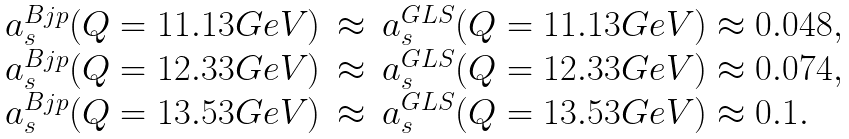<formula> <loc_0><loc_0><loc_500><loc_500>\begin{array} { r c l } a _ { s } ^ { B j p } ( Q = 1 1 . 1 3 G e V ) & \approx & a _ { s } ^ { G L S } ( Q = 1 1 . 1 3 G e V ) \approx 0 . 0 4 8 , \\ a _ { s } ^ { B j p } ( Q = 1 2 . 3 3 G e V ) & \approx & a _ { s } ^ { G L S } ( Q = 1 2 . 3 3 G e V ) \approx 0 . 0 7 4 , \\ a _ { s } ^ { B j p } ( Q = 1 3 . 5 3 G e V ) & \approx & a _ { s } ^ { G L S } ( Q = 1 3 . 5 3 G e V ) \approx 0 . 1 . \end{array}</formula> 